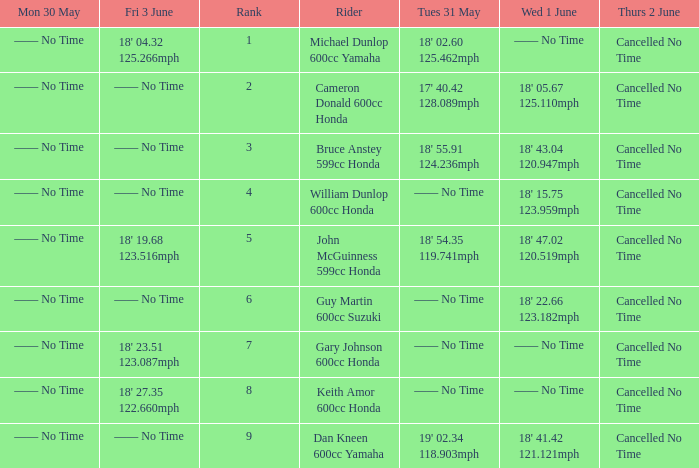Who was the rider with a Fri 3 June time of 18' 19.68 123.516mph? John McGuinness 599cc Honda. Parse the full table. {'header': ['Mon 30 May', 'Fri 3 June', 'Rank', 'Rider', 'Tues 31 May', 'Wed 1 June', 'Thurs 2 June'], 'rows': [['—— No Time', "18' 04.32 125.266mph", '1', 'Michael Dunlop 600cc Yamaha', "18' 02.60 125.462mph", '—— No Time', 'Cancelled No Time'], ['—— No Time', '—— No Time', '2', 'Cameron Donald 600cc Honda', "17' 40.42 128.089mph", "18' 05.67 125.110mph", 'Cancelled No Time'], ['—— No Time', '—— No Time', '3', 'Bruce Anstey 599cc Honda', "18' 55.91 124.236mph", "18' 43.04 120.947mph", 'Cancelled No Time'], ['—— No Time', '—— No Time', '4', 'William Dunlop 600cc Honda', '—— No Time', "18' 15.75 123.959mph", 'Cancelled No Time'], ['—— No Time', "18' 19.68 123.516mph", '5', 'John McGuinness 599cc Honda', "18' 54.35 119.741mph", "18' 47.02 120.519mph", 'Cancelled No Time'], ['—— No Time', '—— No Time', '6', 'Guy Martin 600cc Suzuki', '—— No Time', "18' 22.66 123.182mph", 'Cancelled No Time'], ['—— No Time', "18' 23.51 123.087mph", '7', 'Gary Johnson 600cc Honda', '—— No Time', '—— No Time', 'Cancelled No Time'], ['—— No Time', "18' 27.35 122.660mph", '8', 'Keith Amor 600cc Honda', '—— No Time', '—— No Time', 'Cancelled No Time'], ['—— No Time', '—— No Time', '9', 'Dan Kneen 600cc Yamaha', "19' 02.34 118.903mph", "18' 41.42 121.121mph", 'Cancelled No Time']]} 